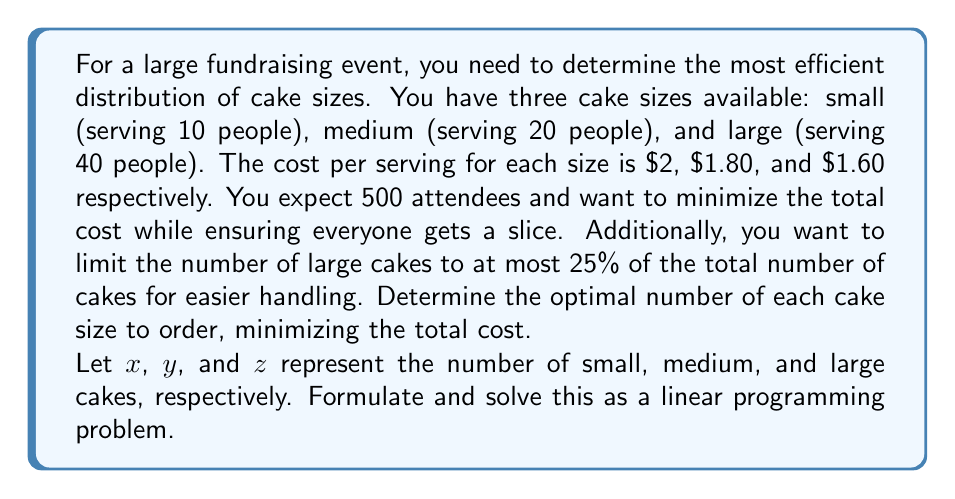Show me your answer to this math problem. To solve this problem, we need to set up a linear programming model and solve it. Let's break it down step by step:

1. Define the objective function:
   We want to minimize the total cost. The cost for each cake size is:
   Small: $2 * 10 = $20
   Medium: $1.80 * 20 = $36
   Large: $1.60 * 40 = $64

   Objective function: Minimize $20x + 36y + 64z$

2. Define the constraints:
   a) Ensure enough servings for all attendees:
      $10x + 20y + 40z \geq 500$

   b) Limit large cakes to at most 25% of total cakes:
      $z \leq 0.25(x + y + z)$
      Simplifying: $3z \leq x + y$

   c) Non-negativity constraints:
      $x, y, z \geq 0$

3. Solve the linear programming problem:
   We can use the simplex method or a linear programming solver to find the optimal solution. After solving, we get:

   $x = 0$ (small cakes)
   $y = 22$ (medium cakes)
   $z = 3$ (large cakes)

4. Verify the solution:
   a) Total servings: $20 * 22 + 40 * 3 = 560 \geq 500$
   b) Large cake constraint: $3 * 3 = 9 \leq 0.25 * (0 + 22 + 3) = 6.25$
   c) All values are non-negative

5. Calculate the total cost:
   Total cost = $36 * 22 + 64 * 3 = $984

This solution provides the most efficient distribution of cake sizes while meeting all constraints and minimizing the total cost.
Answer: The optimal distribution of cake sizes is:
Small cakes: 0
Medium cakes: 22
Large cakes: 3

Total cost: $984 